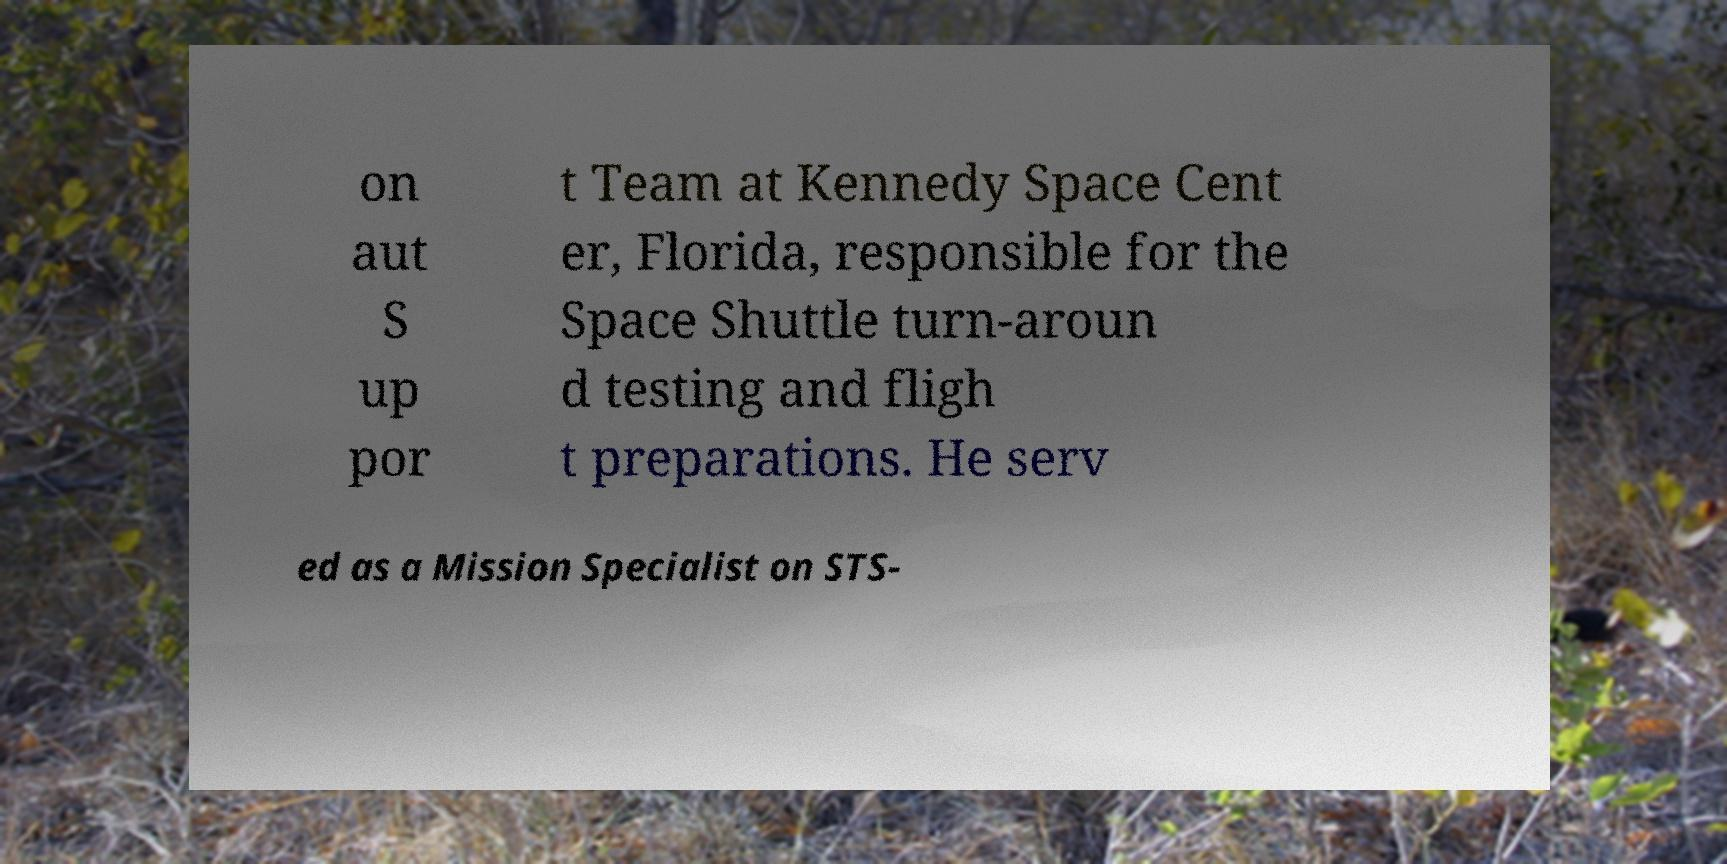Could you extract and type out the text from this image? on aut S up por t Team at Kennedy Space Cent er, Florida, responsible for the Space Shuttle turn-aroun d testing and fligh t preparations. He serv ed as a Mission Specialist on STS- 